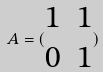<formula> <loc_0><loc_0><loc_500><loc_500>A = ( \begin{matrix} 1 & 1 \\ 0 & 1 \end{matrix} )</formula> 